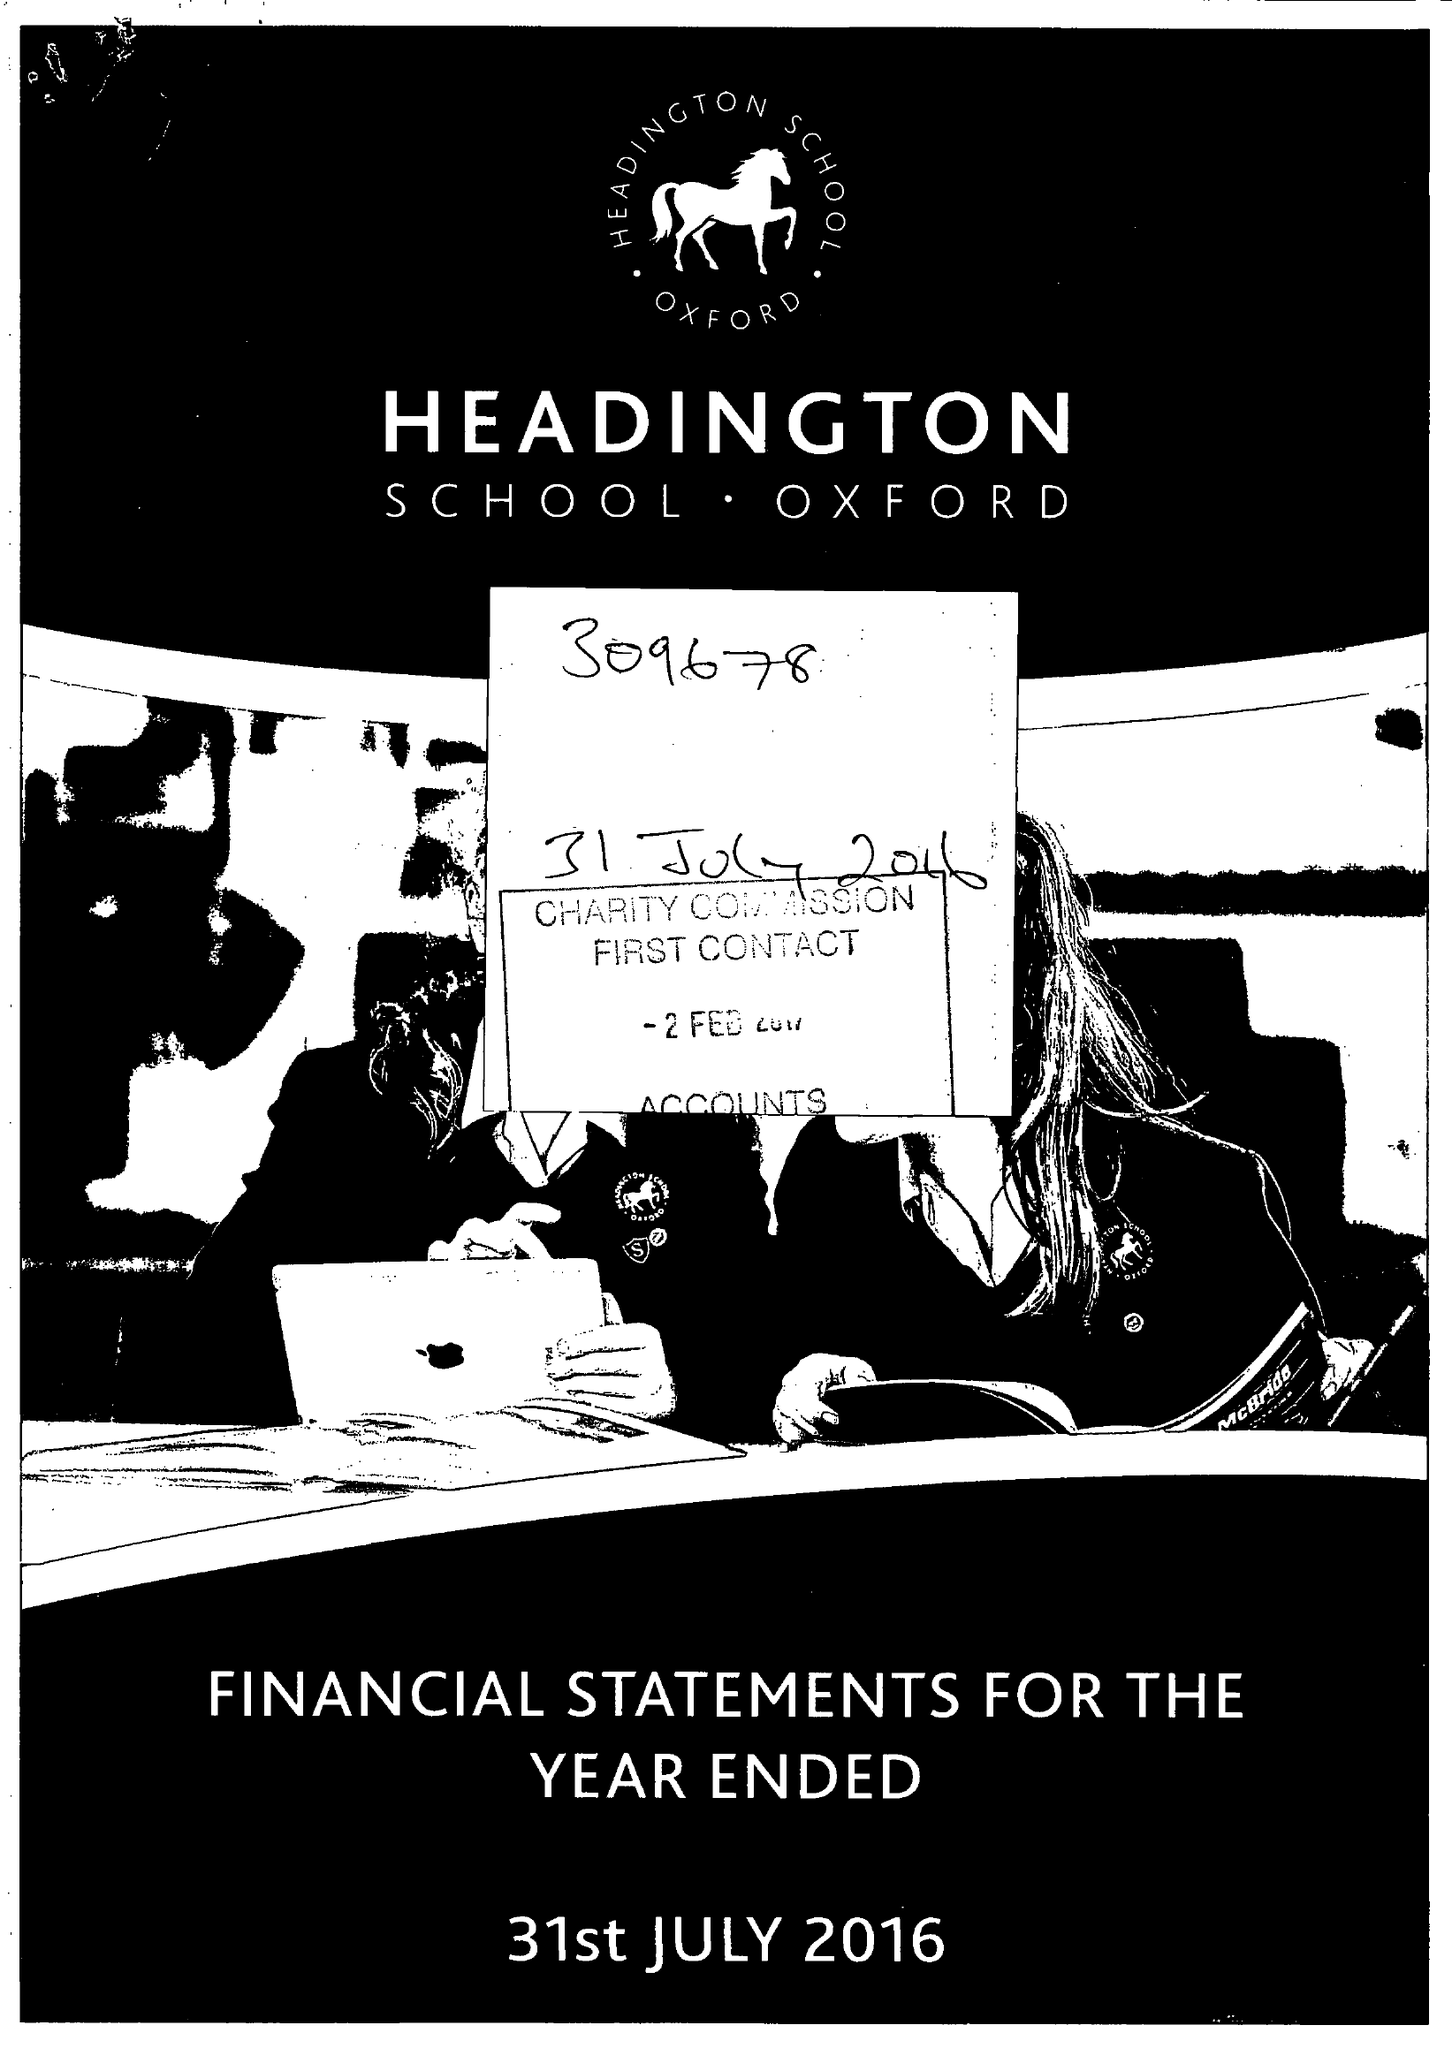What is the value for the charity_number?
Answer the question using a single word or phrase. 309678 